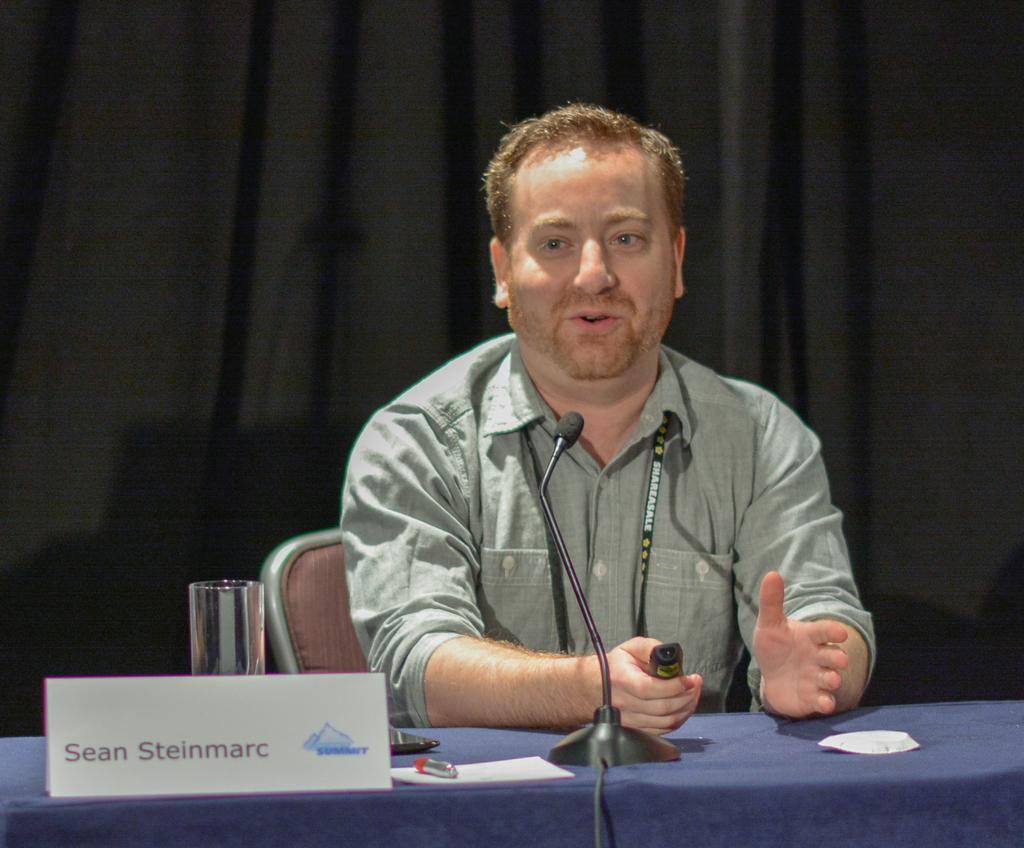Could you give a brief overview of what you see in this image? In the image there is a person sitting in front of a table and speaking something and on the table there is a name card and behind that there is a glass and some other objects. In the background there is a curtain. 